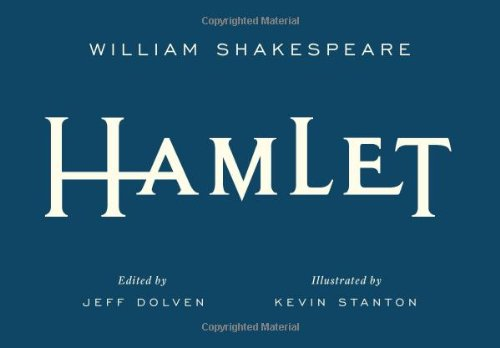Who is the author of this book? The author of the book shown in the image is William Shakespeare, widely acknowledged as one of the greatest playwrights in the English language. 